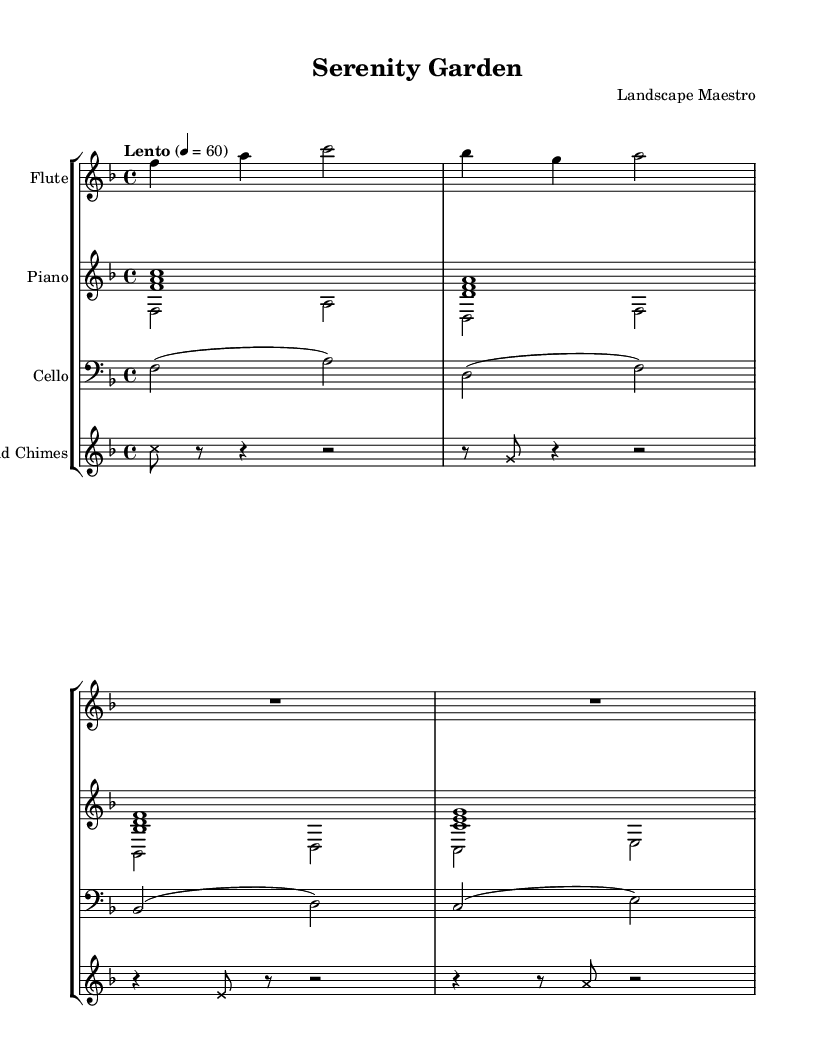What is the key signature of this music? The key signature is indicated by the number of sharps or flats at the beginning of the staff. In this case, there is one flat, which corresponds to F major.
Answer: F major What is the time signature of this piece? The time signature is found at the beginning of the piece, represented by the numbers above the staff. Here, the time signature is 4 over 4, indicating four beats per measure.
Answer: 4/4 What is the tempo marking for this piece? The tempo marking is noted above the staff and gives the speed of the music. In this score, the marking "Lento" means to play slowly, with a metronome marking of 60 beats per minute.
Answer: Lento How many instruments are featured in this piece? The number of staves denoting instruments indicates how many are featured. There are a flute, piano, cello, and wind chimes, totaling four distinct instruments.
Answer: Four What note value is used for the first note of the flute part? The first note of the flute part is notated as a quarter note, which is characterized by being filled in with a stem pointing either up or down, and it occupies one beat.
Answer: Quarter note What dynamic marking is indicated by the wind chimes? The dynamic marking is typically illustrated by symbols indicating the volume to play. In this case, wind chimes use cross note heads, which typically indicate a softer, delicate sound.
Answer: Soft What is the last note played by the piano in the upper voice? The last note in the upper voice of the piano is a G note, which is indicated by the last note of the corresponding measure in the score.
Answer: G 